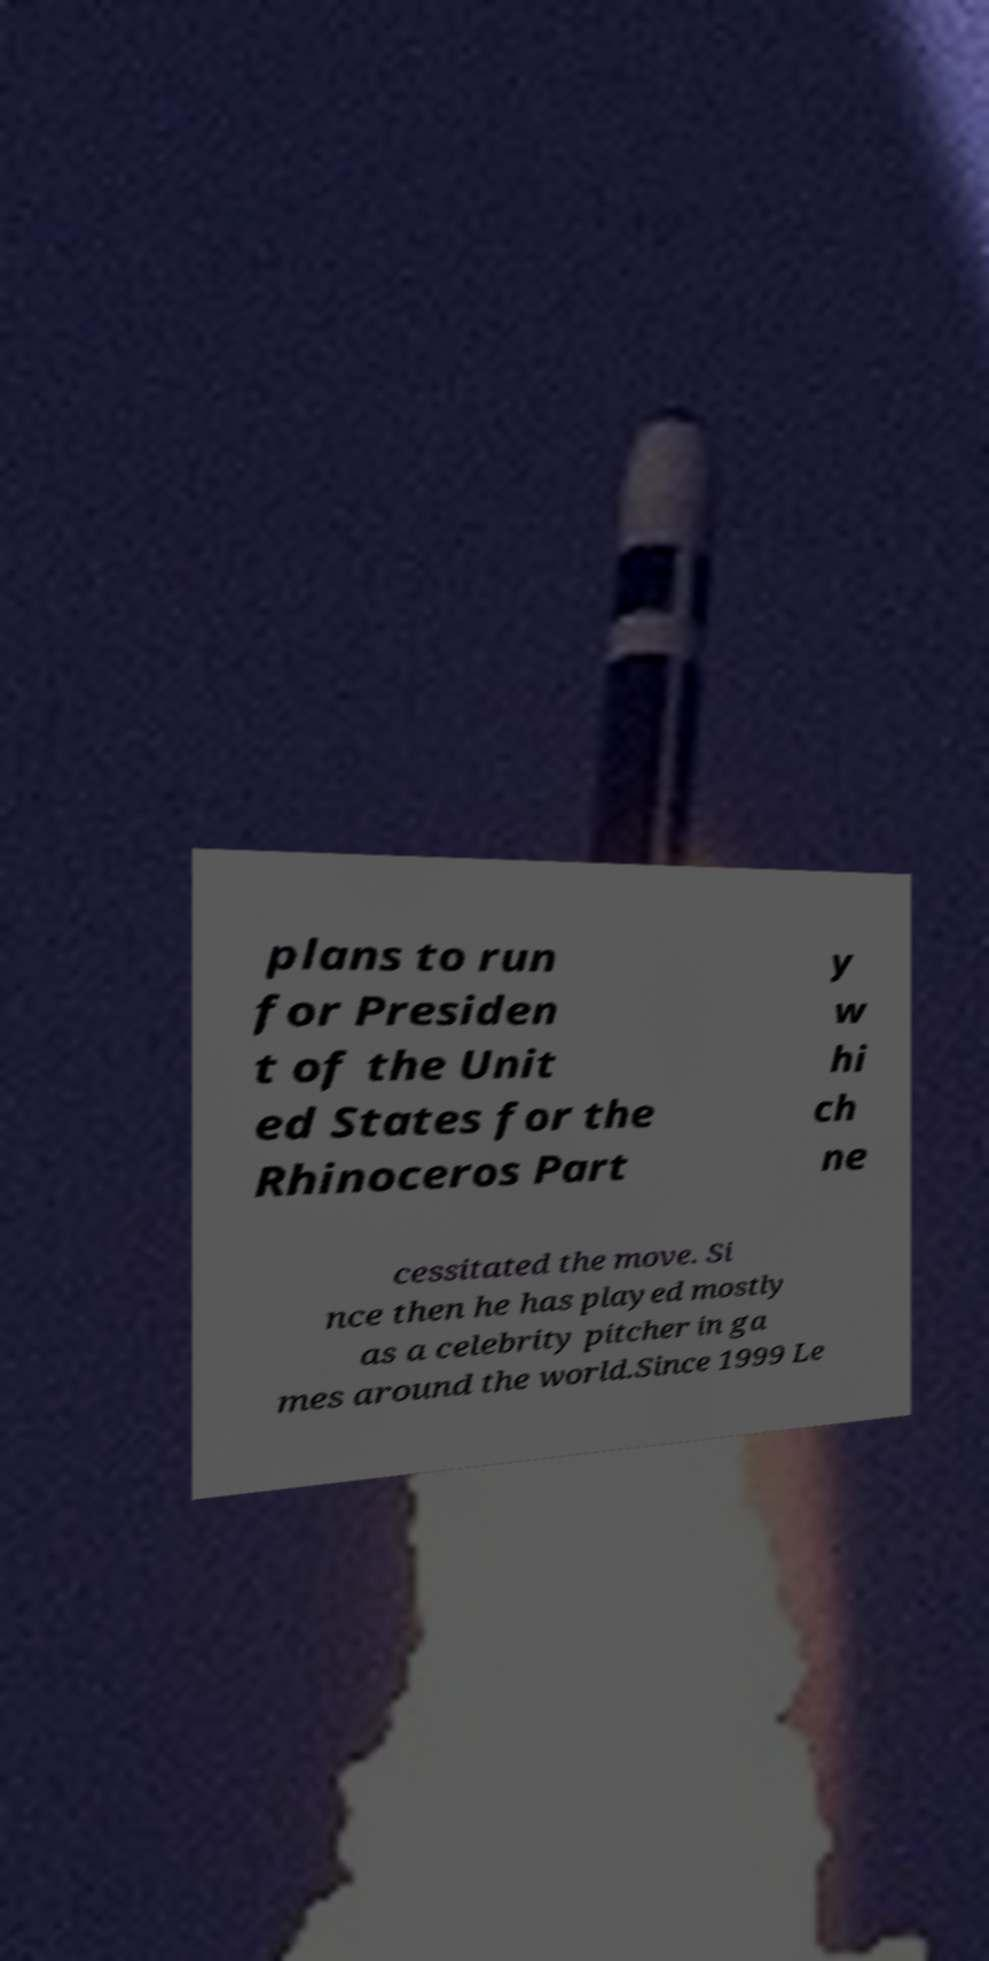Could you extract and type out the text from this image? plans to run for Presiden t of the Unit ed States for the Rhinoceros Part y w hi ch ne cessitated the move. Si nce then he has played mostly as a celebrity pitcher in ga mes around the world.Since 1999 Le 